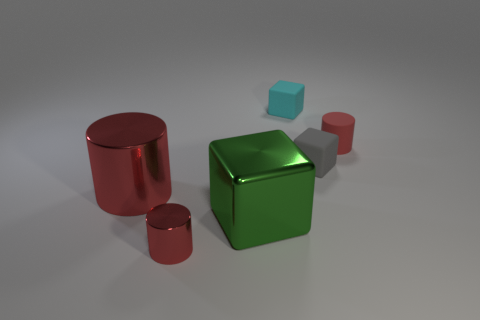Subtract all small matte blocks. How many blocks are left? 1 Add 1 tiny cyan matte cubes. How many objects exist? 7 Add 1 tiny purple matte cylinders. How many tiny purple matte cylinders exist? 1 Subtract 0 brown spheres. How many objects are left? 6 Subtract 3 blocks. How many blocks are left? 0 Subtract all brown blocks. Subtract all yellow cylinders. How many blocks are left? 3 Subtract all gray spheres. How many green cylinders are left? 0 Subtract all small red objects. Subtract all large red rubber cylinders. How many objects are left? 4 Add 5 blocks. How many blocks are left? 8 